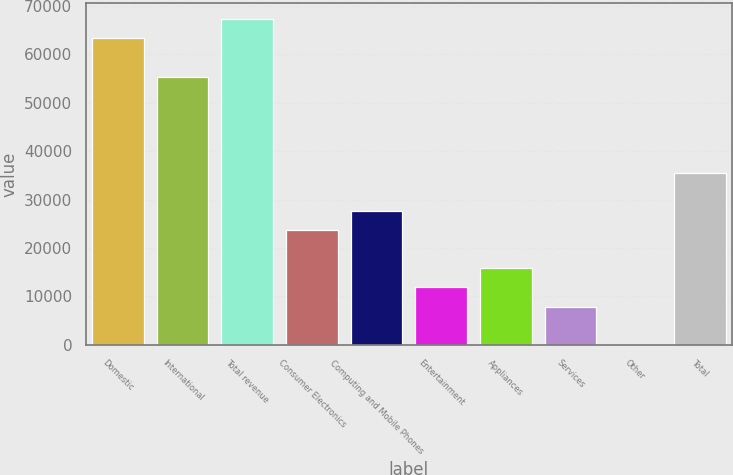Convert chart to OTSL. <chart><loc_0><loc_0><loc_500><loc_500><bar_chart><fcel>Domestic<fcel>International<fcel>Total revenue<fcel>Consumer Electronics<fcel>Computing and Mobile Phones<fcel>Entertainment<fcel>Appliances<fcel>Services<fcel>Other<fcel>Total<nl><fcel>63244.2<fcel>55338.8<fcel>67196.9<fcel>23717.2<fcel>27669.9<fcel>11859.1<fcel>15811.8<fcel>7906.4<fcel>1<fcel>35575.3<nl></chart> 